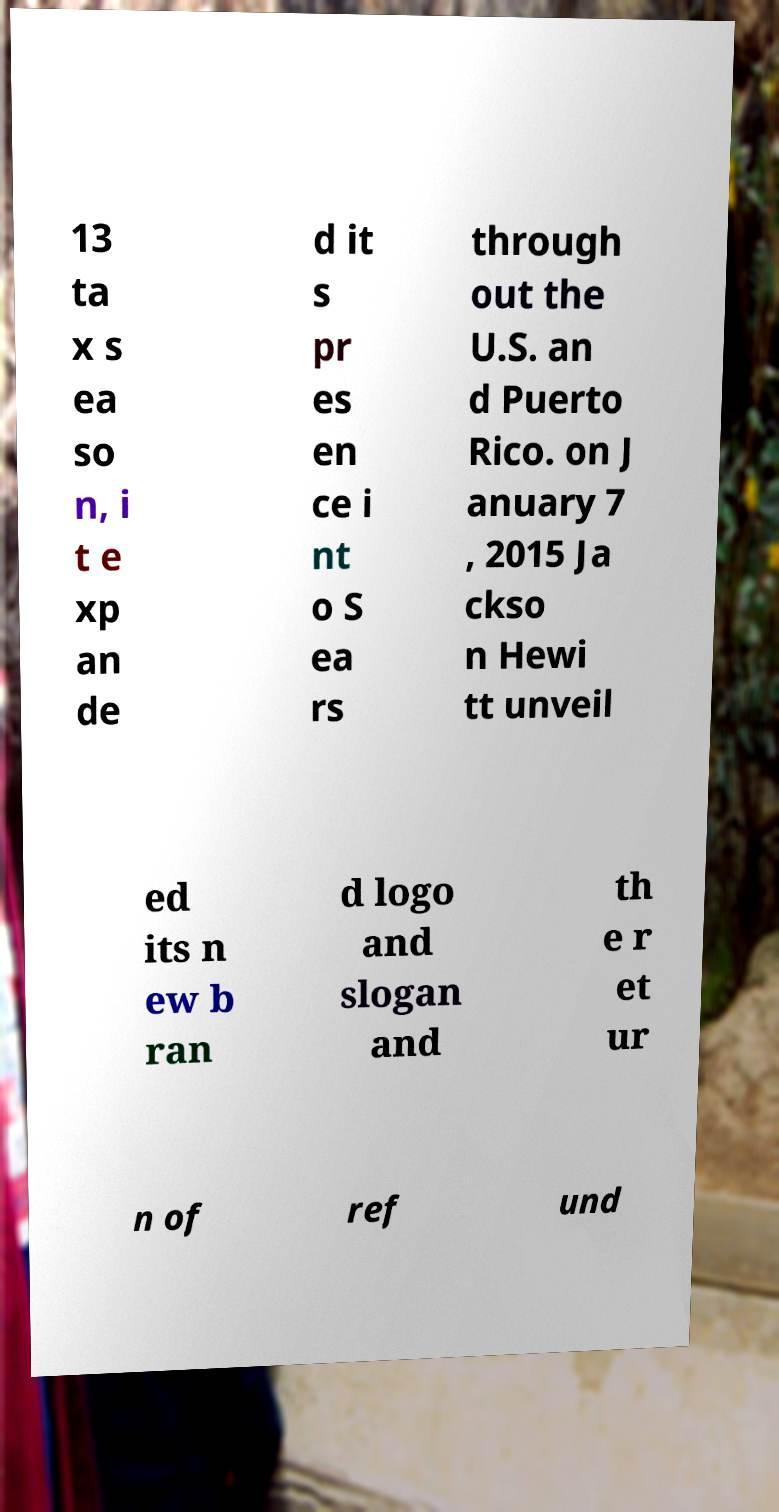Please read and relay the text visible in this image. What does it say? 13 ta x s ea so n, i t e xp an de d it s pr es en ce i nt o S ea rs through out the U.S. an d Puerto Rico. on J anuary 7 , 2015 Ja ckso n Hewi tt unveil ed its n ew b ran d logo and slogan and th e r et ur n of ref und 